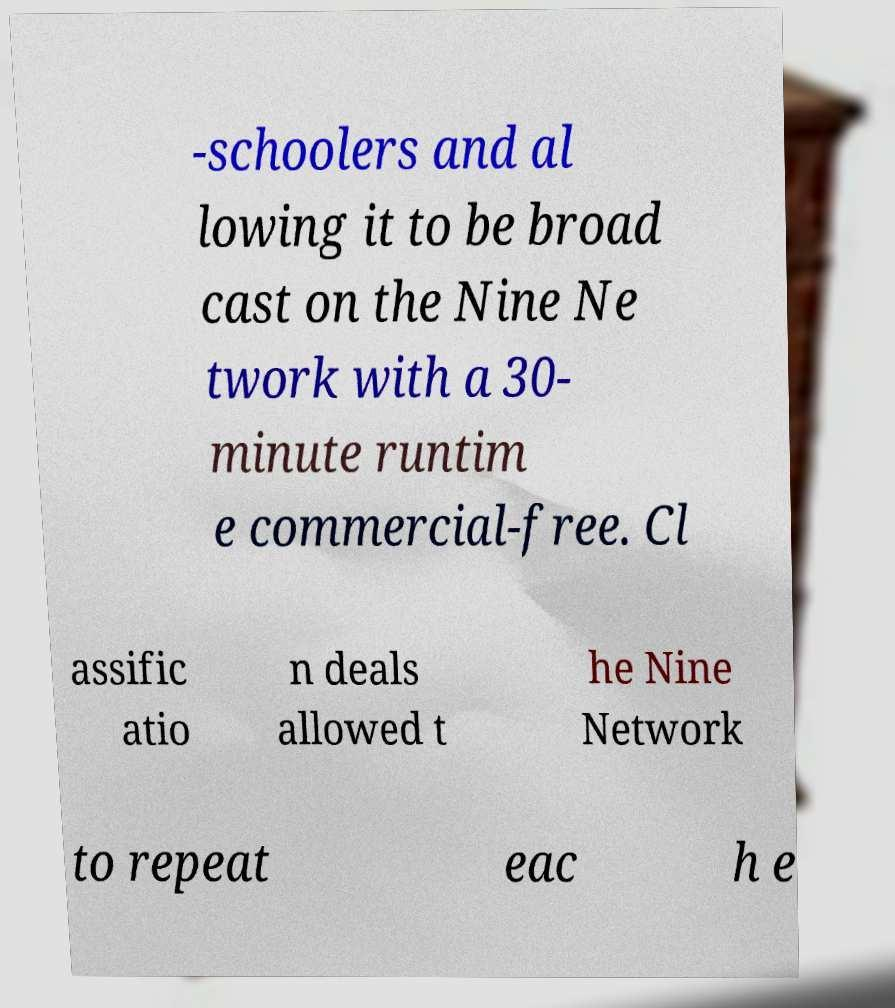Could you assist in decoding the text presented in this image and type it out clearly? -schoolers and al lowing it to be broad cast on the Nine Ne twork with a 30- minute runtim e commercial-free. Cl assific atio n deals allowed t he Nine Network to repeat eac h e 